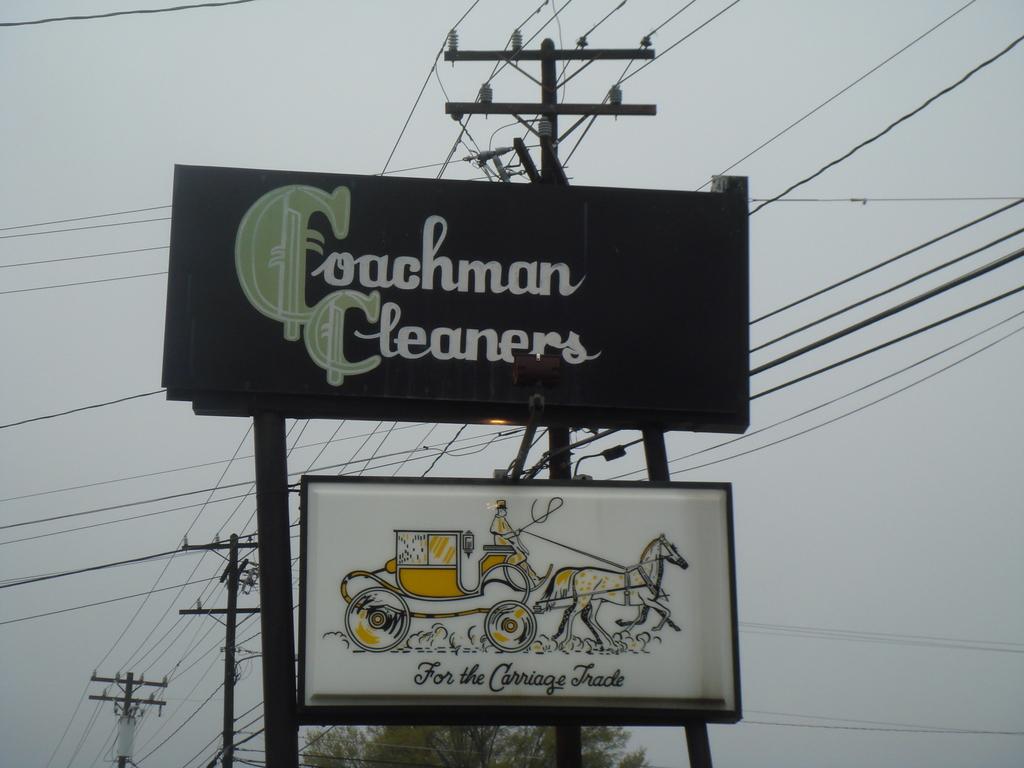What is written on the bottom sign?
Offer a very short reply. For the carriage trade. 